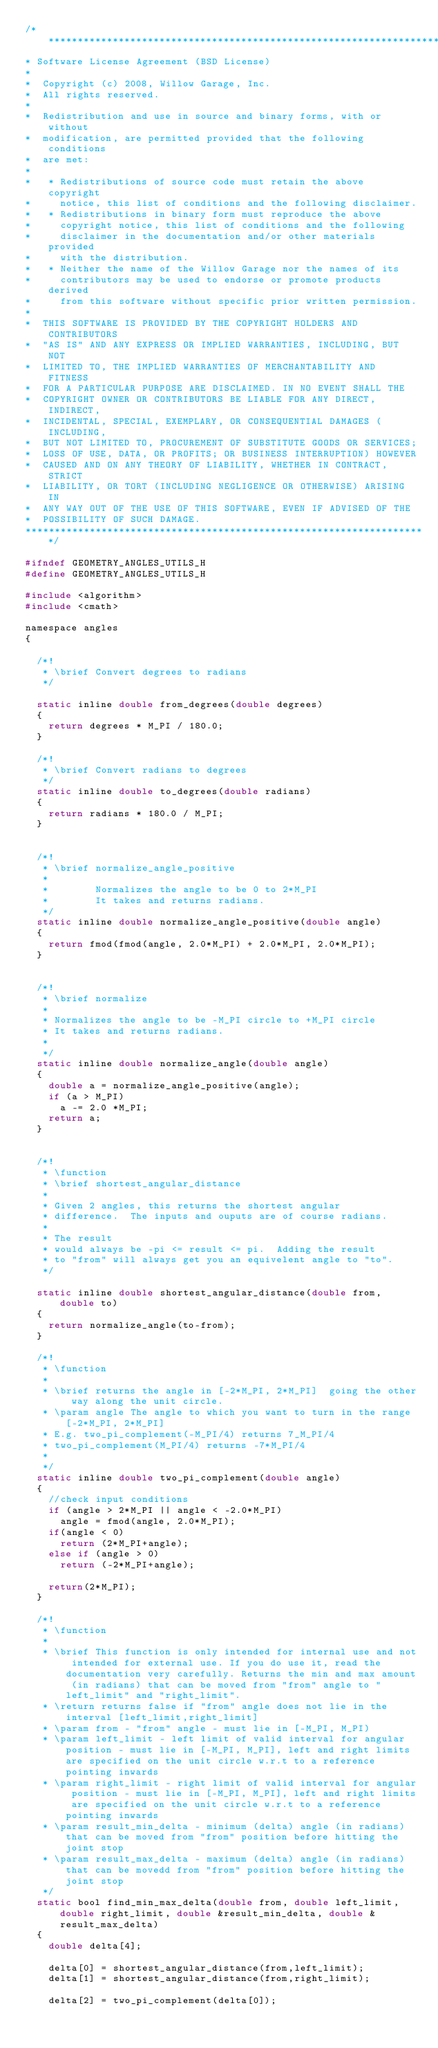<code> <loc_0><loc_0><loc_500><loc_500><_C_>/*********************************************************************
* Software License Agreement (BSD License)
*
*  Copyright (c) 2008, Willow Garage, Inc.
*  All rights reserved.
*
*  Redistribution and use in source and binary forms, with or without
*  modification, are permitted provided that the following conditions
*  are met:
*
*   * Redistributions of source code must retain the above copyright
*     notice, this list of conditions and the following disclaimer.
*   * Redistributions in binary form must reproduce the above
*     copyright notice, this list of conditions and the following
*     disclaimer in the documentation and/or other materials provided
*     with the distribution.
*   * Neither the name of the Willow Garage nor the names of its
*     contributors may be used to endorse or promote products derived
*     from this software without specific prior written permission.
*
*  THIS SOFTWARE IS PROVIDED BY THE COPYRIGHT HOLDERS AND CONTRIBUTORS
*  "AS IS" AND ANY EXPRESS OR IMPLIED WARRANTIES, INCLUDING, BUT NOT
*  LIMITED TO, THE IMPLIED WARRANTIES OF MERCHANTABILITY AND FITNESS
*  FOR A PARTICULAR PURPOSE ARE DISCLAIMED. IN NO EVENT SHALL THE
*  COPYRIGHT OWNER OR CONTRIBUTORS BE LIABLE FOR ANY DIRECT, INDIRECT,
*  INCIDENTAL, SPECIAL, EXEMPLARY, OR CONSEQUENTIAL DAMAGES (INCLUDING,
*  BUT NOT LIMITED TO, PROCUREMENT OF SUBSTITUTE GOODS OR SERVICES;
*  LOSS OF USE, DATA, OR PROFITS; OR BUSINESS INTERRUPTION) HOWEVER
*  CAUSED AND ON ANY THEORY OF LIABILITY, WHETHER IN CONTRACT, STRICT
*  LIABILITY, OR TORT (INCLUDING NEGLIGENCE OR OTHERWISE) ARISING IN
*  ANY WAY OUT OF THE USE OF THIS SOFTWARE, EVEN IF ADVISED OF THE
*  POSSIBILITY OF SUCH DAMAGE.
*********************************************************************/

#ifndef GEOMETRY_ANGLES_UTILS_H
#define GEOMETRY_ANGLES_UTILS_H

#include <algorithm>
#include <cmath>

namespace angles
{

  /*!
   * \brief Convert degrees to radians
   */

  static inline double from_degrees(double degrees)
  {
    return degrees * M_PI / 180.0;
  }

  /*!
   * \brief Convert radians to degrees
   */
  static inline double to_degrees(double radians)
  {
    return radians * 180.0 / M_PI;
  }


  /*!
   * \brief normalize_angle_positive
   *
   *        Normalizes the angle to be 0 to 2*M_PI
   *        It takes and returns radians.
   */
  static inline double normalize_angle_positive(double angle)
  {
    return fmod(fmod(angle, 2.0*M_PI) + 2.0*M_PI, 2.0*M_PI);
  }


  /*!
   * \brief normalize
   *
   * Normalizes the angle to be -M_PI circle to +M_PI circle
   * It takes and returns radians.
   *
   */
  static inline double normalize_angle(double angle)
  {
    double a = normalize_angle_positive(angle);
    if (a > M_PI)
      a -= 2.0 *M_PI;
    return a;
  }


  /*!
   * \function
   * \brief shortest_angular_distance
   *
   * Given 2 angles, this returns the shortest angular
   * difference.  The inputs and ouputs are of course radians.
   *
   * The result
   * would always be -pi <= result <= pi.  Adding the result
   * to "from" will always get you an equivelent angle to "to".
   */

  static inline double shortest_angular_distance(double from, double to)
  {
    return normalize_angle(to-from);
  }

  /*!
   * \function
   *
   * \brief returns the angle in [-2*M_PI, 2*M_PI]  going the other way along the unit circle.
   * \param angle The angle to which you want to turn in the range [-2*M_PI, 2*M_PI]
   * E.g. two_pi_complement(-M_PI/4) returns 7_M_PI/4
   * two_pi_complement(M_PI/4) returns -7*M_PI/4
   *
   */
  static inline double two_pi_complement(double angle)
  {
    //check input conditions
    if (angle > 2*M_PI || angle < -2.0*M_PI)
      angle = fmod(angle, 2.0*M_PI);
    if(angle < 0)
      return (2*M_PI+angle);
    else if (angle > 0)
      return (-2*M_PI+angle);

    return(2*M_PI);
  }

  /*!
   * \function
   *
   * \brief This function is only intended for internal use and not intended for external use. If you do use it, read the documentation very carefully. Returns the min and max amount (in radians) that can be moved from "from" angle to "left_limit" and "right_limit".
   * \return returns false if "from" angle does not lie in the interval [left_limit,right_limit]
   * \param from - "from" angle - must lie in [-M_PI, M_PI)
   * \param left_limit - left limit of valid interval for angular position - must lie in [-M_PI, M_PI], left and right limits are specified on the unit circle w.r.t to a reference pointing inwards
   * \param right_limit - right limit of valid interval for angular position - must lie in [-M_PI, M_PI], left and right limits are specified on the unit circle w.r.t to a reference pointing inwards
   * \param result_min_delta - minimum (delta) angle (in radians) that can be moved from "from" position before hitting the joint stop
   * \param result_max_delta - maximum (delta) angle (in radians) that can be movedd from "from" position before hitting the joint stop
   */
  static bool find_min_max_delta(double from, double left_limit, double right_limit, double &result_min_delta, double &result_max_delta)
  {
    double delta[4];

    delta[0] = shortest_angular_distance(from,left_limit);
    delta[1] = shortest_angular_distance(from,right_limit);

    delta[2] = two_pi_complement(delta[0]);</code> 